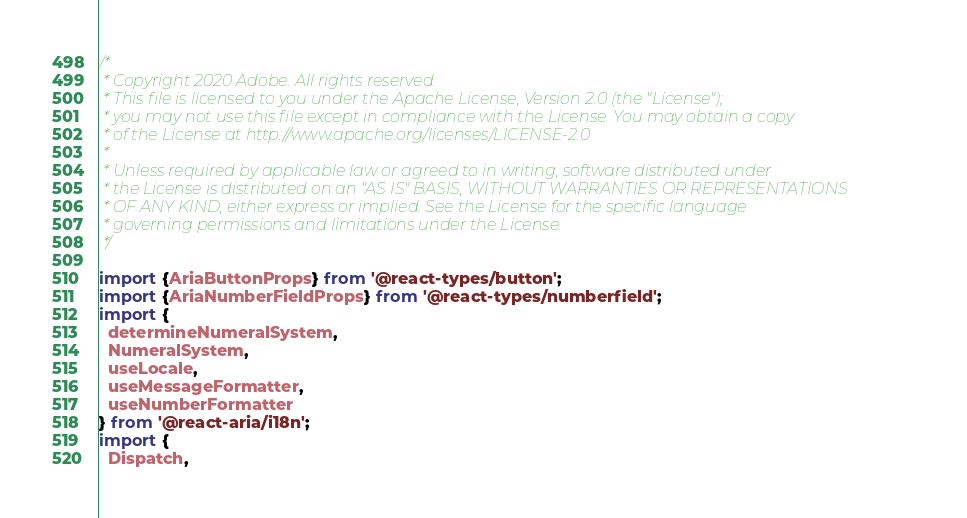Convert code to text. <code><loc_0><loc_0><loc_500><loc_500><_TypeScript_>/*
 * Copyright 2020 Adobe. All rights reserved.
 * This file is licensed to you under the Apache License, Version 2.0 (the "License");
 * you may not use this file except in compliance with the License. You may obtain a copy
 * of the License at http://www.apache.org/licenses/LICENSE-2.0
 *
 * Unless required by applicable law or agreed to in writing, software distributed under
 * the License is distributed on an "AS IS" BASIS, WITHOUT WARRANTIES OR REPRESENTATIONS
 * OF ANY KIND, either express or implied. See the License for the specific language
 * governing permissions and limitations under the License.
 */

import {AriaButtonProps} from '@react-types/button';
import {AriaNumberFieldProps} from '@react-types/numberfield';
import {
  determineNumeralSystem,
  NumeralSystem,
  useLocale,
  useMessageFormatter,
  useNumberFormatter
} from '@react-aria/i18n';
import {
  Dispatch,</code> 